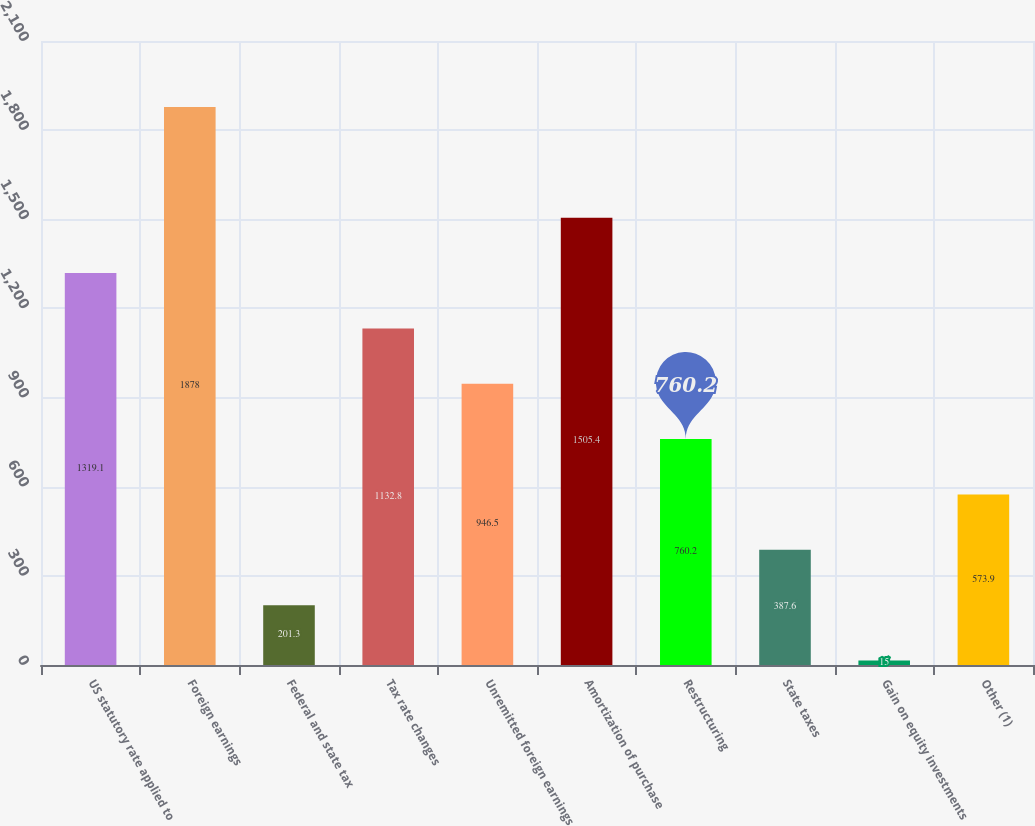Convert chart. <chart><loc_0><loc_0><loc_500><loc_500><bar_chart><fcel>US statutory rate applied to<fcel>Foreign earnings<fcel>Federal and state tax<fcel>Tax rate changes<fcel>Unremitted foreign earnings<fcel>Amortization of purchase<fcel>Restructuring<fcel>State taxes<fcel>Gain on equity investments<fcel>Other (1)<nl><fcel>1319.1<fcel>1878<fcel>201.3<fcel>1132.8<fcel>946.5<fcel>1505.4<fcel>760.2<fcel>387.6<fcel>15<fcel>573.9<nl></chart> 